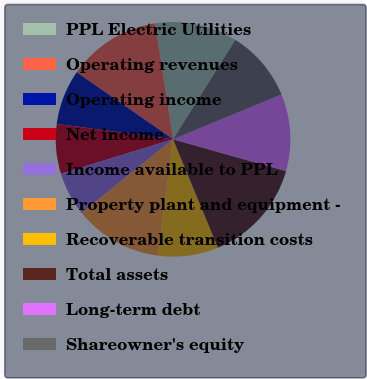Convert chart. <chart><loc_0><loc_0><loc_500><loc_500><pie_chart><fcel>PPL Electric Utilities<fcel>Operating revenues<fcel>Operating income<fcel>Net income<fcel>Income available to PPL<fcel>Property plant and equipment -<fcel>Recoverable transition costs<fcel>Total assets<fcel>Long-term debt<fcel>Shareowner's equity<nl><fcel>11.36%<fcel>12.88%<fcel>7.58%<fcel>6.82%<fcel>6.06%<fcel>12.12%<fcel>8.33%<fcel>14.39%<fcel>10.61%<fcel>9.85%<nl></chart> 